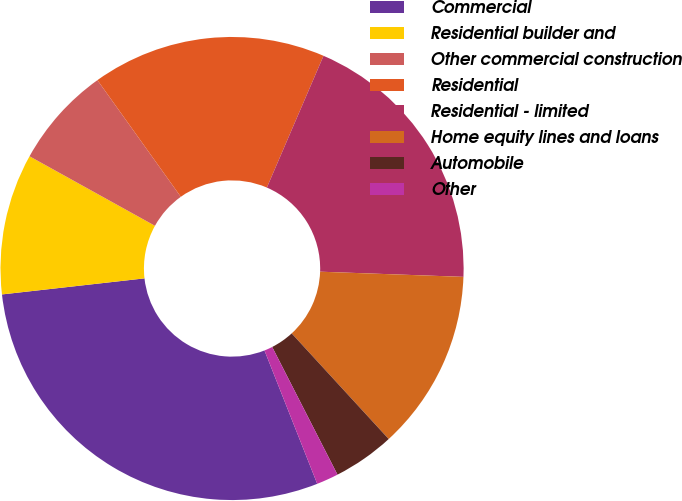Convert chart. <chart><loc_0><loc_0><loc_500><loc_500><pie_chart><fcel>Commercial<fcel>Residential builder and<fcel>Other commercial construction<fcel>Residential<fcel>Residential - limited<fcel>Home equity lines and loans<fcel>Automobile<fcel>Other<nl><fcel>29.21%<fcel>9.84%<fcel>7.07%<fcel>16.34%<fcel>19.11%<fcel>12.6%<fcel>4.3%<fcel>1.53%<nl></chart> 